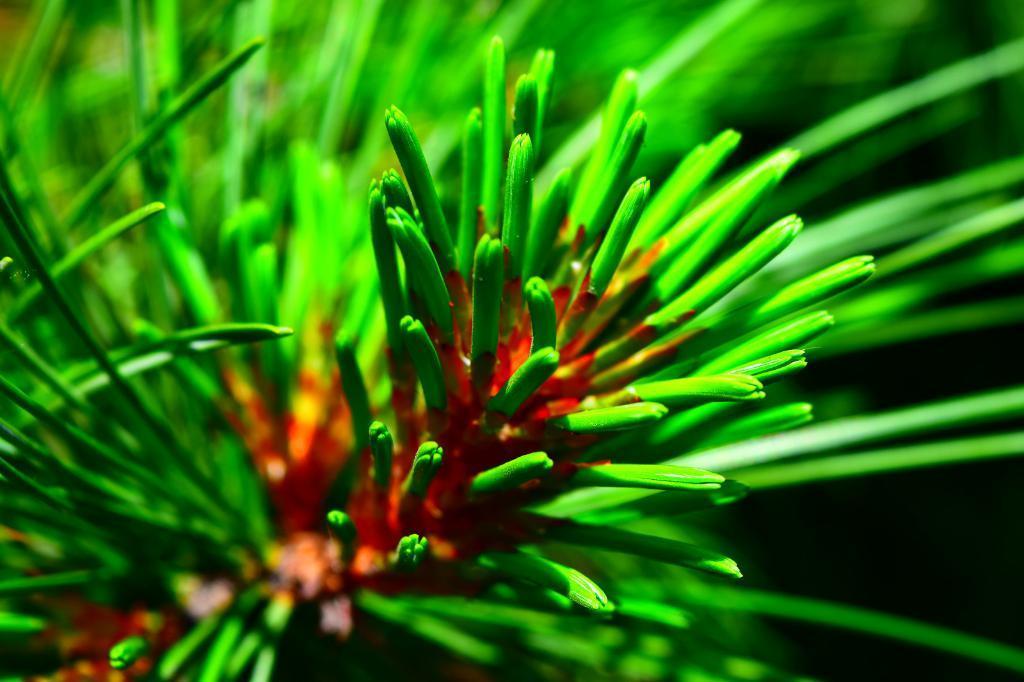Please provide a concise description of this image. As we can see in the image there are plants and red color flowers. 